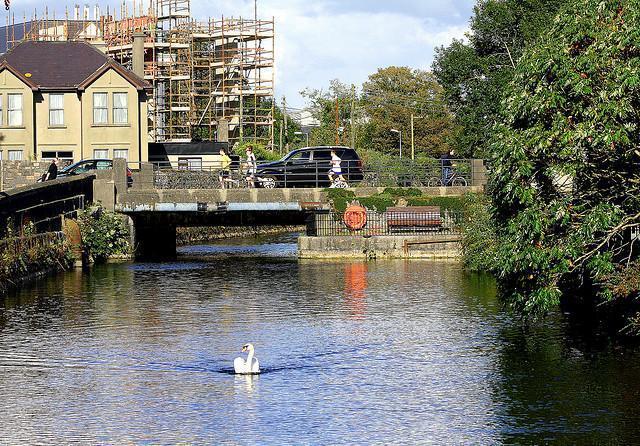How many people are in the water?
Give a very brief answer. 0. How many buses are there?
Give a very brief answer. 0. 